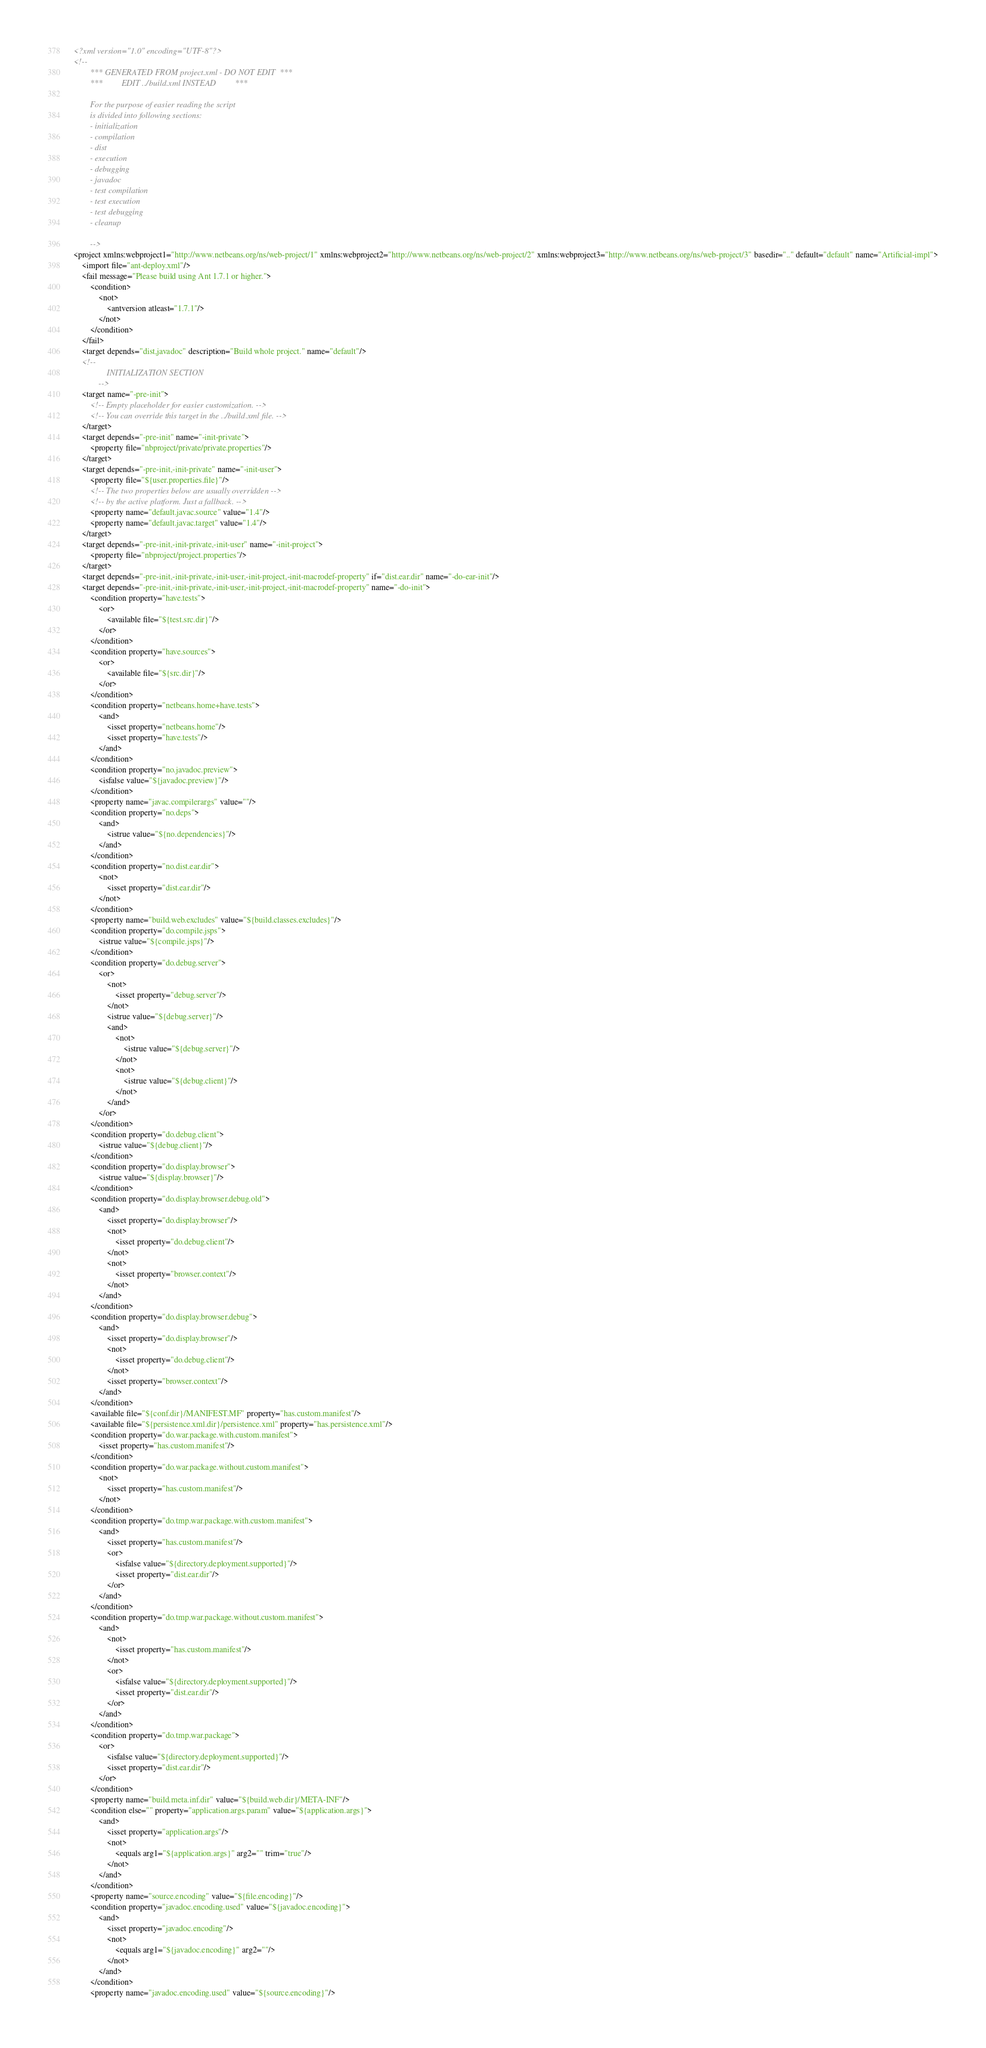Convert code to text. <code><loc_0><loc_0><loc_500><loc_500><_XML_><?xml version="1.0" encoding="UTF-8"?>
<!--
        *** GENERATED FROM project.xml - DO NOT EDIT  ***
        ***         EDIT ../build.xml INSTEAD         ***

        For the purpose of easier reading the script
        is divided into following sections:
        - initialization
        - compilation
        - dist
        - execution
        - debugging
        - javadoc
        - test compilation
        - test execution
        - test debugging
        - cleanup

        -->
<project xmlns:webproject1="http://www.netbeans.org/ns/web-project/1" xmlns:webproject2="http://www.netbeans.org/ns/web-project/2" xmlns:webproject3="http://www.netbeans.org/ns/web-project/3" basedir=".." default="default" name="Artificial-impl">
    <import file="ant-deploy.xml"/>
    <fail message="Please build using Ant 1.7.1 or higher.">
        <condition>
            <not>
                <antversion atleast="1.7.1"/>
            </not>
        </condition>
    </fail>
    <target depends="dist,javadoc" description="Build whole project." name="default"/>
    <!--
                INITIALIZATION SECTION
            -->
    <target name="-pre-init">
        <!-- Empty placeholder for easier customization. -->
        <!-- You can override this target in the ../build.xml file. -->
    </target>
    <target depends="-pre-init" name="-init-private">
        <property file="nbproject/private/private.properties"/>
    </target>
    <target depends="-pre-init,-init-private" name="-init-user">
        <property file="${user.properties.file}"/>
        <!-- The two properties below are usually overridden -->
        <!-- by the active platform. Just a fallback. -->
        <property name="default.javac.source" value="1.4"/>
        <property name="default.javac.target" value="1.4"/>
    </target>
    <target depends="-pre-init,-init-private,-init-user" name="-init-project">
        <property file="nbproject/project.properties"/>
    </target>
    <target depends="-pre-init,-init-private,-init-user,-init-project,-init-macrodef-property" if="dist.ear.dir" name="-do-ear-init"/>
    <target depends="-pre-init,-init-private,-init-user,-init-project,-init-macrodef-property" name="-do-init">
        <condition property="have.tests">
            <or>
                <available file="${test.src.dir}"/>
            </or>
        </condition>
        <condition property="have.sources">
            <or>
                <available file="${src.dir}"/>
            </or>
        </condition>
        <condition property="netbeans.home+have.tests">
            <and>
                <isset property="netbeans.home"/>
                <isset property="have.tests"/>
            </and>
        </condition>
        <condition property="no.javadoc.preview">
            <isfalse value="${javadoc.preview}"/>
        </condition>
        <property name="javac.compilerargs" value=""/>
        <condition property="no.deps">
            <and>
                <istrue value="${no.dependencies}"/>
            </and>
        </condition>
        <condition property="no.dist.ear.dir">
            <not>
                <isset property="dist.ear.dir"/>
            </not>
        </condition>
        <property name="build.web.excludes" value="${build.classes.excludes}"/>
        <condition property="do.compile.jsps">
            <istrue value="${compile.jsps}"/>
        </condition>
        <condition property="do.debug.server">
            <or>
                <not>
                    <isset property="debug.server"/>
                </not>
                <istrue value="${debug.server}"/>
                <and>
                    <not>
                        <istrue value="${debug.server}"/>
                    </not>
                    <not>
                        <istrue value="${debug.client}"/>
                    </not>
                </and>
            </or>
        </condition>
        <condition property="do.debug.client">
            <istrue value="${debug.client}"/>
        </condition>
        <condition property="do.display.browser">
            <istrue value="${display.browser}"/>
        </condition>
        <condition property="do.display.browser.debug.old">
            <and>
                <isset property="do.display.browser"/>
                <not>
                    <isset property="do.debug.client"/>
                </not>
                <not>
                    <isset property="browser.context"/>
                </not>
            </and>
        </condition>
        <condition property="do.display.browser.debug">
            <and>
                <isset property="do.display.browser"/>
                <not>
                    <isset property="do.debug.client"/>
                </not>
                <isset property="browser.context"/>
            </and>
        </condition>
        <available file="${conf.dir}/MANIFEST.MF" property="has.custom.manifest"/>
        <available file="${persistence.xml.dir}/persistence.xml" property="has.persistence.xml"/>
        <condition property="do.war.package.with.custom.manifest">
            <isset property="has.custom.manifest"/>
        </condition>
        <condition property="do.war.package.without.custom.manifest">
            <not>
                <isset property="has.custom.manifest"/>
            </not>
        </condition>
        <condition property="do.tmp.war.package.with.custom.manifest">
            <and>
                <isset property="has.custom.manifest"/>
                <or>
                    <isfalse value="${directory.deployment.supported}"/>
                    <isset property="dist.ear.dir"/>
                </or>
            </and>
        </condition>
        <condition property="do.tmp.war.package.without.custom.manifest">
            <and>
                <not>
                    <isset property="has.custom.manifest"/>
                </not>
                <or>
                    <isfalse value="${directory.deployment.supported}"/>
                    <isset property="dist.ear.dir"/>
                </or>
            </and>
        </condition>
        <condition property="do.tmp.war.package">
            <or>
                <isfalse value="${directory.deployment.supported}"/>
                <isset property="dist.ear.dir"/>
            </or>
        </condition>
        <property name="build.meta.inf.dir" value="${build.web.dir}/META-INF"/>
        <condition else="" property="application.args.param" value="${application.args}">
            <and>
                <isset property="application.args"/>
                <not>
                    <equals arg1="${application.args}" arg2="" trim="true"/>
                </not>
            </and>
        </condition>
        <property name="source.encoding" value="${file.encoding}"/>
        <condition property="javadoc.encoding.used" value="${javadoc.encoding}">
            <and>
                <isset property="javadoc.encoding"/>
                <not>
                    <equals arg1="${javadoc.encoding}" arg2=""/>
                </not>
            </and>
        </condition>
        <property name="javadoc.encoding.used" value="${source.encoding}"/></code> 